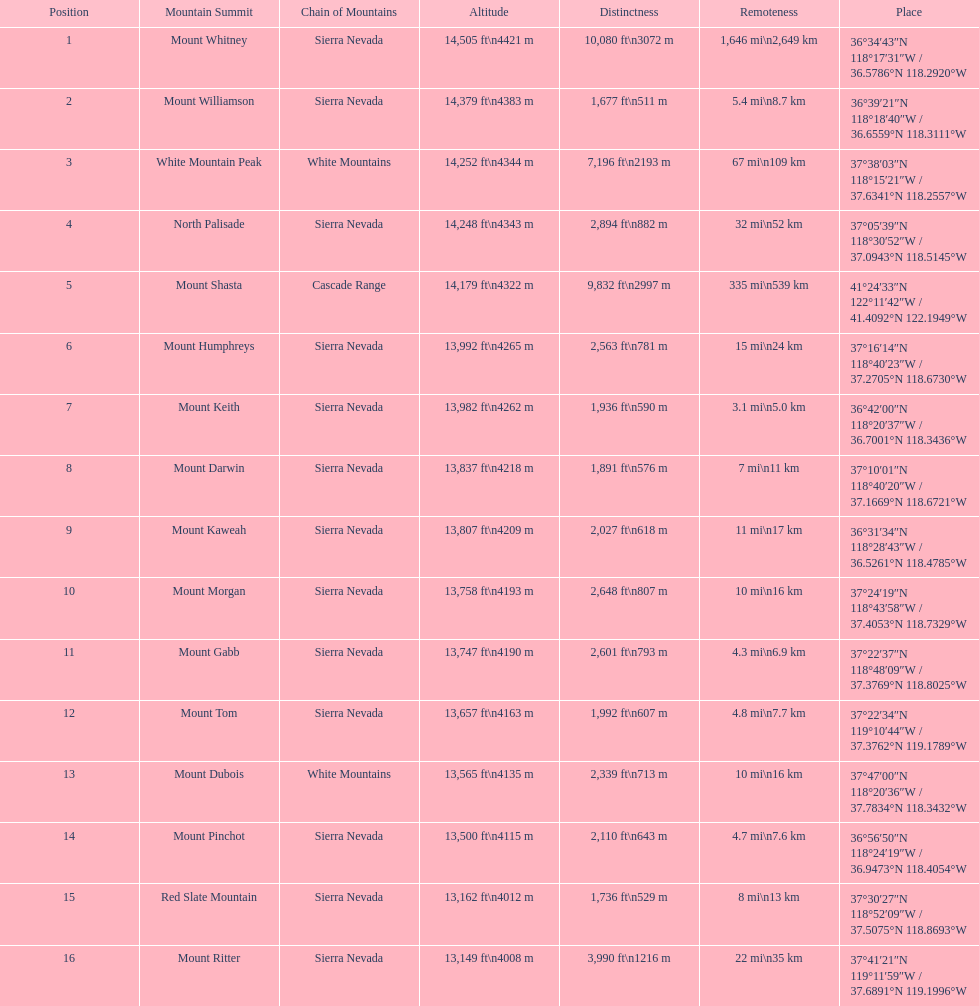Which mountain peak has the most isolation? Mount Whitney. 